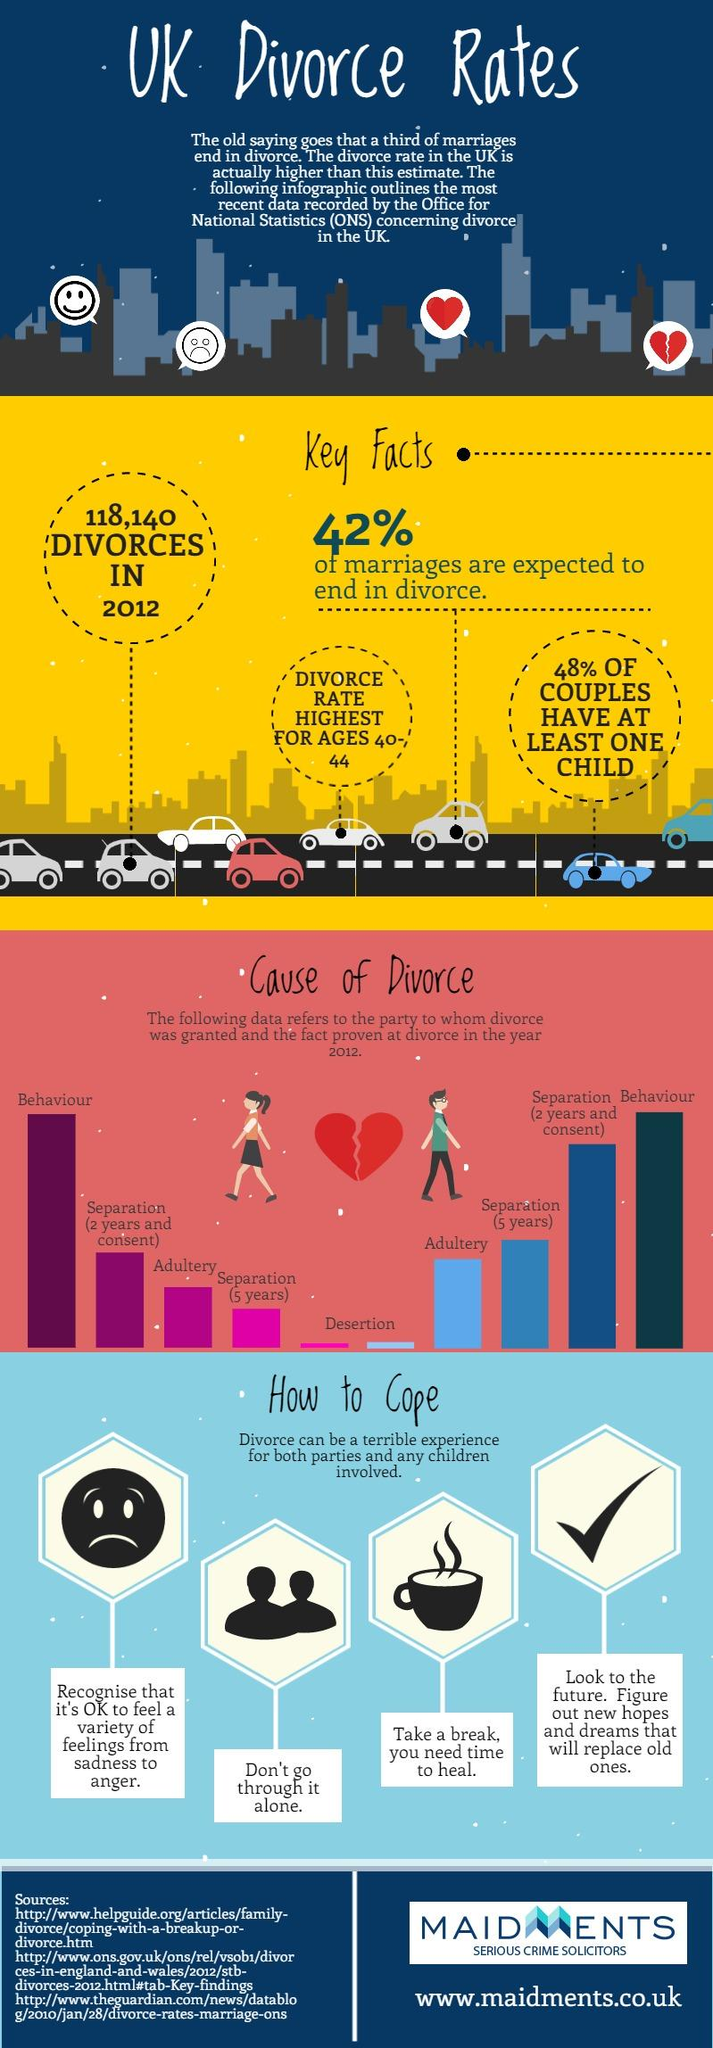Draw attention to some important aspects in this diagram. In the year 2012, the third most common reason for men to be granted a divorce was separation after a period of five years. In the year 2012, the second highest reason for men to be granted a divorce was separation, specifically separation that had occurred for two years with the consent of both parties. Adultery was the third most common reason for women to be granted a divorce in the year 2012, according to statistics. According to statistics, the age group with the highest divorce rate is 40-44 years old. 